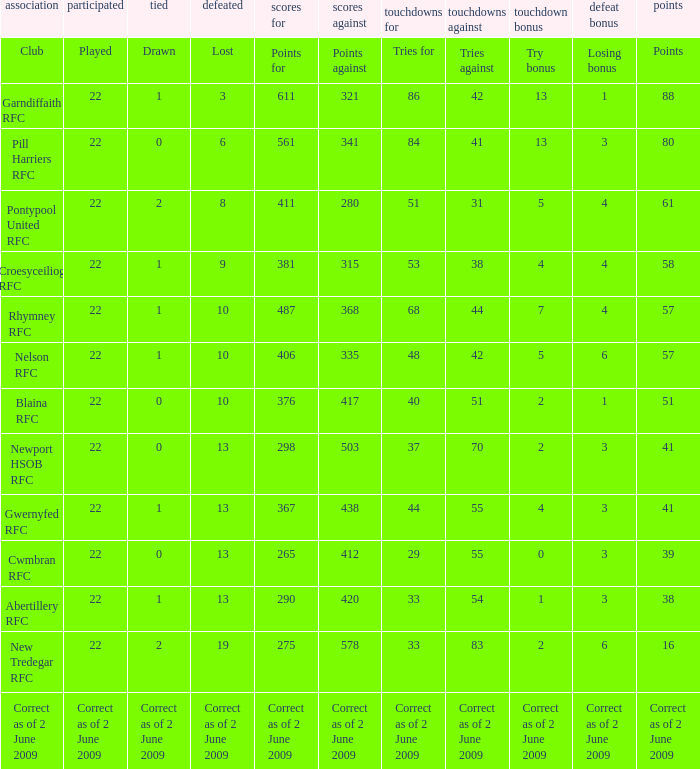How many tries did the club Croesyceiliog rfc have? 53.0. 